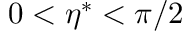<formula> <loc_0><loc_0><loc_500><loc_500>0 < \eta ^ { \ast } < \pi / 2</formula> 